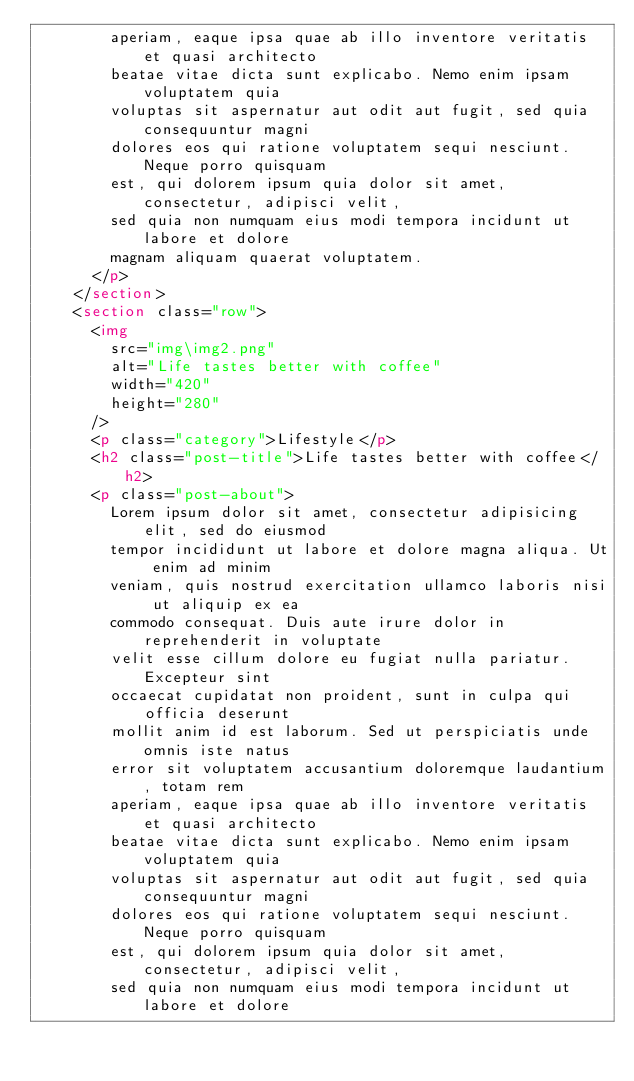Convert code to text. <code><loc_0><loc_0><loc_500><loc_500><_HTML_>        aperiam, eaque ipsa quae ab illo inventore veritatis et quasi architecto
        beatae vitae dicta sunt explicabo. Nemo enim ipsam voluptatem quia
        voluptas sit aspernatur aut odit aut fugit, sed quia consequuntur magni
        dolores eos qui ratione voluptatem sequi nesciunt. Neque porro quisquam
        est, qui dolorem ipsum quia dolor sit amet, consectetur, adipisci velit,
        sed quia non numquam eius modi tempora incidunt ut labore et dolore
        magnam aliquam quaerat voluptatem.
      </p>
    </section>
    <section class="row">
      <img
        src="img\img2.png"
        alt="Life tastes better with coffee"
        width="420"
        height="280"
      />
      <p class="category">Lifestyle</p>
      <h2 class="post-title">Life tastes better with coffee</h2>
      <p class="post-about">
        Lorem ipsum dolor sit amet, consectetur adipisicing elit, sed do eiusmod
        tempor incididunt ut labore et dolore magna aliqua. Ut enim ad minim
        veniam, quis nostrud exercitation ullamco laboris nisi ut aliquip ex ea
        commodo consequat. Duis aute irure dolor in reprehenderit in voluptate
        velit esse cillum dolore eu fugiat nulla pariatur. Excepteur sint
        occaecat cupidatat non proident, sunt in culpa qui officia deserunt
        mollit anim id est laborum. Sed ut perspiciatis unde omnis iste natus
        error sit voluptatem accusantium doloremque laudantium, totam rem
        aperiam, eaque ipsa quae ab illo inventore veritatis et quasi architecto
        beatae vitae dicta sunt explicabo. Nemo enim ipsam voluptatem quia
        voluptas sit aspernatur aut odit aut fugit, sed quia consequuntur magni
        dolores eos qui ratione voluptatem sequi nesciunt. Neque porro quisquam
        est, qui dolorem ipsum quia dolor sit amet, consectetur, adipisci velit,
        sed quia non numquam eius modi tempora incidunt ut labore et dolore</code> 